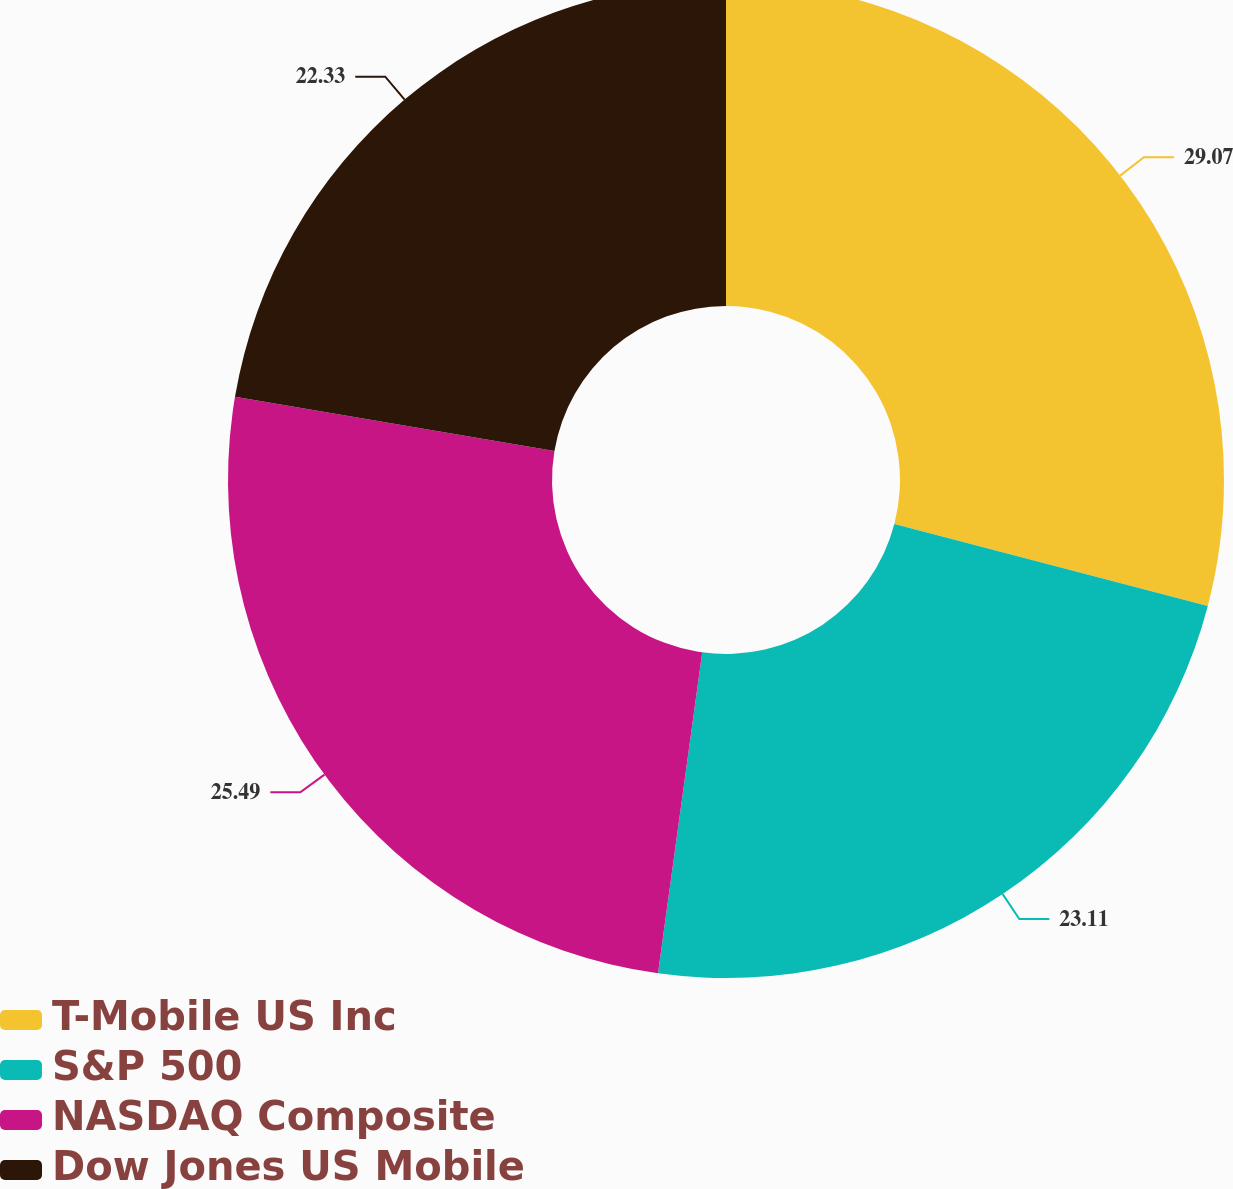Convert chart to OTSL. <chart><loc_0><loc_0><loc_500><loc_500><pie_chart><fcel>T-Mobile US Inc<fcel>S&P 500<fcel>NASDAQ Composite<fcel>Dow Jones US Mobile<nl><fcel>29.07%<fcel>23.11%<fcel>25.49%<fcel>22.33%<nl></chart> 